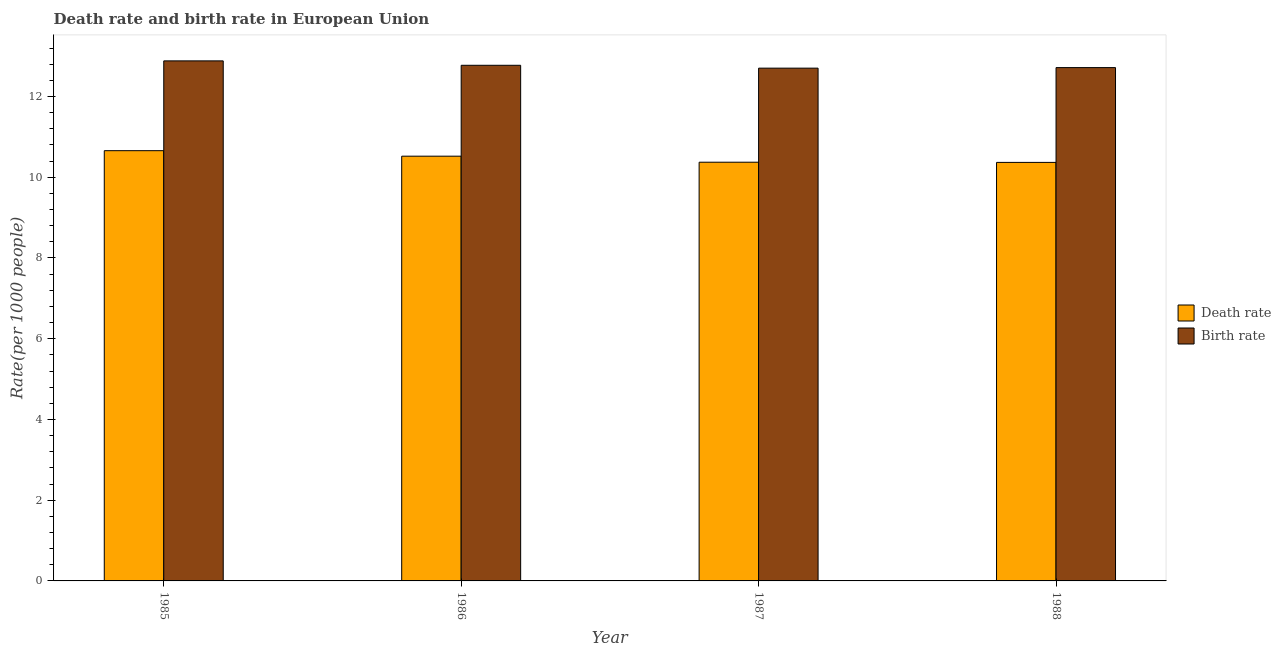Are the number of bars per tick equal to the number of legend labels?
Keep it short and to the point. Yes. Are the number of bars on each tick of the X-axis equal?
Offer a very short reply. Yes. What is the label of the 2nd group of bars from the left?
Keep it short and to the point. 1986. What is the death rate in 1988?
Make the answer very short. 10.37. Across all years, what is the maximum death rate?
Offer a terse response. 10.66. Across all years, what is the minimum death rate?
Offer a very short reply. 10.37. In which year was the death rate minimum?
Your answer should be compact. 1988. What is the total birth rate in the graph?
Keep it short and to the point. 51.07. What is the difference between the death rate in 1986 and that in 1988?
Your response must be concise. 0.15. What is the difference between the birth rate in 1988 and the death rate in 1987?
Keep it short and to the point. 0.01. What is the average birth rate per year?
Keep it short and to the point. 12.77. In the year 1988, what is the difference between the death rate and birth rate?
Give a very brief answer. 0. In how many years, is the birth rate greater than 10.4?
Keep it short and to the point. 4. What is the ratio of the birth rate in 1987 to that in 1988?
Ensure brevity in your answer.  1. Is the death rate in 1987 less than that in 1988?
Your answer should be very brief. No. Is the difference between the death rate in 1985 and 1987 greater than the difference between the birth rate in 1985 and 1987?
Your answer should be very brief. No. What is the difference between the highest and the second highest birth rate?
Your answer should be compact. 0.11. What is the difference between the highest and the lowest birth rate?
Keep it short and to the point. 0.18. In how many years, is the birth rate greater than the average birth rate taken over all years?
Your answer should be very brief. 2. Is the sum of the death rate in 1986 and 1988 greater than the maximum birth rate across all years?
Offer a very short reply. Yes. What does the 1st bar from the left in 1985 represents?
Make the answer very short. Death rate. What does the 1st bar from the right in 1985 represents?
Offer a terse response. Birth rate. How many bars are there?
Provide a succinct answer. 8. Are all the bars in the graph horizontal?
Your response must be concise. No. How many years are there in the graph?
Make the answer very short. 4. What is the difference between two consecutive major ticks on the Y-axis?
Offer a terse response. 2. Does the graph contain any zero values?
Offer a terse response. No. Does the graph contain grids?
Give a very brief answer. No. How many legend labels are there?
Your response must be concise. 2. What is the title of the graph?
Offer a terse response. Death rate and birth rate in European Union. What is the label or title of the Y-axis?
Your answer should be compact. Rate(per 1000 people). What is the Rate(per 1000 people) of Death rate in 1985?
Your answer should be very brief. 10.66. What is the Rate(per 1000 people) in Birth rate in 1985?
Your response must be concise. 12.88. What is the Rate(per 1000 people) in Death rate in 1986?
Offer a terse response. 10.52. What is the Rate(per 1000 people) of Birth rate in 1986?
Ensure brevity in your answer.  12.77. What is the Rate(per 1000 people) in Death rate in 1987?
Provide a succinct answer. 10.37. What is the Rate(per 1000 people) of Birth rate in 1987?
Give a very brief answer. 12.7. What is the Rate(per 1000 people) in Death rate in 1988?
Your answer should be very brief. 10.37. What is the Rate(per 1000 people) of Birth rate in 1988?
Ensure brevity in your answer.  12.72. Across all years, what is the maximum Rate(per 1000 people) of Death rate?
Offer a terse response. 10.66. Across all years, what is the maximum Rate(per 1000 people) of Birth rate?
Keep it short and to the point. 12.88. Across all years, what is the minimum Rate(per 1000 people) of Death rate?
Ensure brevity in your answer.  10.37. Across all years, what is the minimum Rate(per 1000 people) of Birth rate?
Your response must be concise. 12.7. What is the total Rate(per 1000 people) of Death rate in the graph?
Your response must be concise. 41.92. What is the total Rate(per 1000 people) of Birth rate in the graph?
Your answer should be very brief. 51.07. What is the difference between the Rate(per 1000 people) of Death rate in 1985 and that in 1986?
Keep it short and to the point. 0.14. What is the difference between the Rate(per 1000 people) of Birth rate in 1985 and that in 1986?
Make the answer very short. 0.11. What is the difference between the Rate(per 1000 people) in Death rate in 1985 and that in 1987?
Offer a very short reply. 0.29. What is the difference between the Rate(per 1000 people) of Birth rate in 1985 and that in 1987?
Provide a succinct answer. 0.18. What is the difference between the Rate(per 1000 people) of Death rate in 1985 and that in 1988?
Offer a very short reply. 0.29. What is the difference between the Rate(per 1000 people) in Birth rate in 1985 and that in 1988?
Your answer should be compact. 0.17. What is the difference between the Rate(per 1000 people) of Death rate in 1986 and that in 1987?
Your answer should be compact. 0.15. What is the difference between the Rate(per 1000 people) of Birth rate in 1986 and that in 1987?
Make the answer very short. 0.07. What is the difference between the Rate(per 1000 people) of Death rate in 1986 and that in 1988?
Keep it short and to the point. 0.15. What is the difference between the Rate(per 1000 people) of Birth rate in 1986 and that in 1988?
Your response must be concise. 0.06. What is the difference between the Rate(per 1000 people) of Death rate in 1987 and that in 1988?
Give a very brief answer. 0. What is the difference between the Rate(per 1000 people) of Birth rate in 1987 and that in 1988?
Offer a terse response. -0.01. What is the difference between the Rate(per 1000 people) in Death rate in 1985 and the Rate(per 1000 people) in Birth rate in 1986?
Offer a terse response. -2.12. What is the difference between the Rate(per 1000 people) in Death rate in 1985 and the Rate(per 1000 people) in Birth rate in 1987?
Offer a very short reply. -2.04. What is the difference between the Rate(per 1000 people) of Death rate in 1985 and the Rate(per 1000 people) of Birth rate in 1988?
Your answer should be compact. -2.06. What is the difference between the Rate(per 1000 people) in Death rate in 1986 and the Rate(per 1000 people) in Birth rate in 1987?
Ensure brevity in your answer.  -2.18. What is the difference between the Rate(per 1000 people) in Death rate in 1986 and the Rate(per 1000 people) in Birth rate in 1988?
Your response must be concise. -2.19. What is the difference between the Rate(per 1000 people) in Death rate in 1987 and the Rate(per 1000 people) in Birth rate in 1988?
Your answer should be compact. -2.34. What is the average Rate(per 1000 people) in Death rate per year?
Your answer should be compact. 10.48. What is the average Rate(per 1000 people) in Birth rate per year?
Offer a terse response. 12.77. In the year 1985, what is the difference between the Rate(per 1000 people) of Death rate and Rate(per 1000 people) of Birth rate?
Make the answer very short. -2.22. In the year 1986, what is the difference between the Rate(per 1000 people) of Death rate and Rate(per 1000 people) of Birth rate?
Your answer should be very brief. -2.25. In the year 1987, what is the difference between the Rate(per 1000 people) of Death rate and Rate(per 1000 people) of Birth rate?
Provide a succinct answer. -2.33. In the year 1988, what is the difference between the Rate(per 1000 people) of Death rate and Rate(per 1000 people) of Birth rate?
Your answer should be very brief. -2.35. What is the ratio of the Rate(per 1000 people) of Death rate in 1985 to that in 1986?
Your answer should be compact. 1.01. What is the ratio of the Rate(per 1000 people) in Birth rate in 1985 to that in 1986?
Give a very brief answer. 1.01. What is the ratio of the Rate(per 1000 people) in Death rate in 1985 to that in 1987?
Provide a short and direct response. 1.03. What is the ratio of the Rate(per 1000 people) of Birth rate in 1985 to that in 1987?
Offer a very short reply. 1.01. What is the ratio of the Rate(per 1000 people) in Death rate in 1985 to that in 1988?
Provide a succinct answer. 1.03. What is the ratio of the Rate(per 1000 people) in Birth rate in 1985 to that in 1988?
Your answer should be compact. 1.01. What is the ratio of the Rate(per 1000 people) of Death rate in 1986 to that in 1987?
Offer a terse response. 1.01. What is the ratio of the Rate(per 1000 people) of Birth rate in 1986 to that in 1987?
Your response must be concise. 1.01. What is the ratio of the Rate(per 1000 people) of Death rate in 1986 to that in 1988?
Make the answer very short. 1.01. What is the ratio of the Rate(per 1000 people) of Birth rate in 1986 to that in 1988?
Your answer should be compact. 1. What is the ratio of the Rate(per 1000 people) in Death rate in 1987 to that in 1988?
Your answer should be compact. 1. What is the ratio of the Rate(per 1000 people) of Birth rate in 1987 to that in 1988?
Give a very brief answer. 1. What is the difference between the highest and the second highest Rate(per 1000 people) of Death rate?
Offer a terse response. 0.14. What is the difference between the highest and the second highest Rate(per 1000 people) of Birth rate?
Make the answer very short. 0.11. What is the difference between the highest and the lowest Rate(per 1000 people) of Death rate?
Provide a short and direct response. 0.29. What is the difference between the highest and the lowest Rate(per 1000 people) in Birth rate?
Provide a short and direct response. 0.18. 